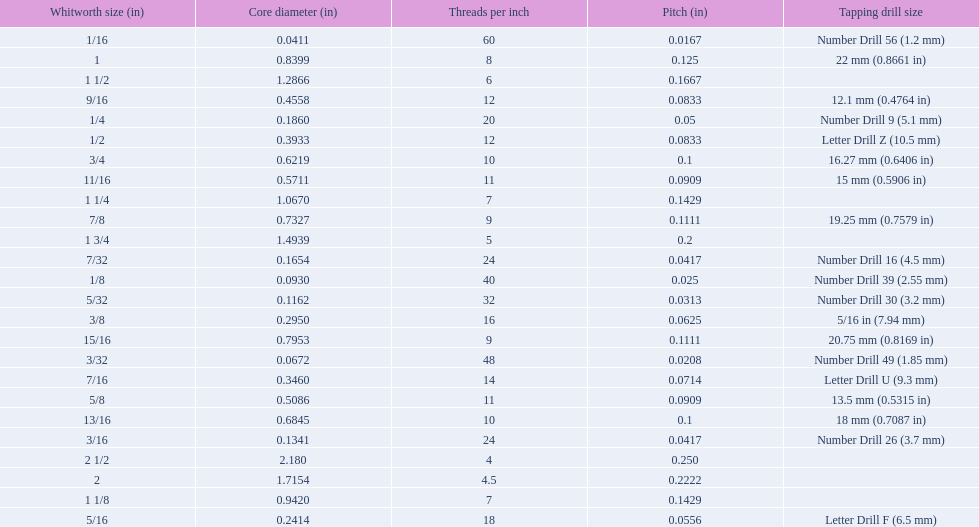What is the core diameter of the first 1/8 whitworth size (in)? 0.0930. Write the full table. {'header': ['Whitworth size (in)', 'Core diameter (in)', 'Threads per\xa0inch', 'Pitch (in)', 'Tapping drill size'], 'rows': [['1/16', '0.0411', '60', '0.0167', 'Number Drill 56 (1.2\xa0mm)'], ['1', '0.8399', '8', '0.125', '22\xa0mm (0.8661\xa0in)'], ['1 1/2', '1.2866', '6', '0.1667', ''], ['9/16', '0.4558', '12', '0.0833', '12.1\xa0mm (0.4764\xa0in)'], ['1/4', '0.1860', '20', '0.05', 'Number Drill 9 (5.1\xa0mm)'], ['1/2', '0.3933', '12', '0.0833', 'Letter Drill Z (10.5\xa0mm)'], ['3/4', '0.6219', '10', '0.1', '16.27\xa0mm (0.6406\xa0in)'], ['11/16', '0.5711', '11', '0.0909', '15\xa0mm (0.5906\xa0in)'], ['1 1/4', '1.0670', '7', '0.1429', ''], ['7/8', '0.7327', '9', '0.1111', '19.25\xa0mm (0.7579\xa0in)'], ['1 3/4', '1.4939', '5', '0.2', ''], ['7/32', '0.1654', '24', '0.0417', 'Number Drill 16 (4.5\xa0mm)'], ['1/8', '0.0930', '40', '0.025', 'Number Drill 39 (2.55\xa0mm)'], ['5/32', '0.1162', '32', '0.0313', 'Number Drill 30 (3.2\xa0mm)'], ['3/8', '0.2950', '16', '0.0625', '5/16\xa0in (7.94\xa0mm)'], ['15/16', '0.7953', '9', '0.1111', '20.75\xa0mm (0.8169\xa0in)'], ['3/32', '0.0672', '48', '0.0208', 'Number Drill 49 (1.85\xa0mm)'], ['7/16', '0.3460', '14', '0.0714', 'Letter Drill U (9.3\xa0mm)'], ['5/8', '0.5086', '11', '0.0909', '13.5\xa0mm (0.5315\xa0in)'], ['13/16', '0.6845', '10', '0.1', '18\xa0mm (0.7087\xa0in)'], ['3/16', '0.1341', '24', '0.0417', 'Number Drill 26 (3.7\xa0mm)'], ['2 1/2', '2.180', '4', '0.250', ''], ['2', '1.7154', '4.5', '0.2222', ''], ['1 1/8', '0.9420', '7', '0.1429', ''], ['5/16', '0.2414', '18', '0.0556', 'Letter Drill F (6.5\xa0mm)']]} 